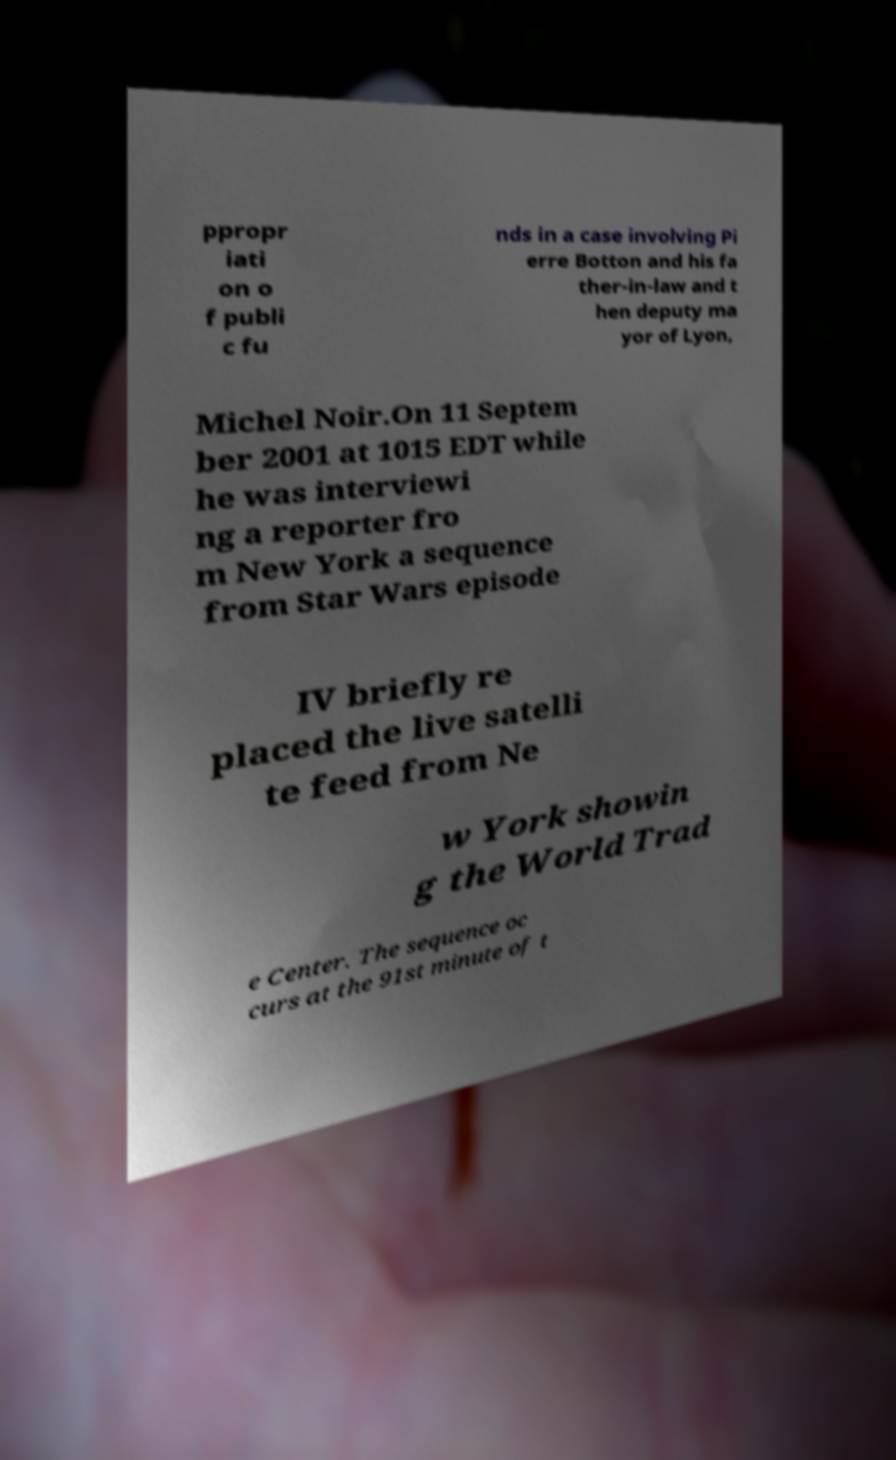Please identify and transcribe the text found in this image. ppropr iati on o f publi c fu nds in a case involving Pi erre Botton and his fa ther-in-law and t hen deputy ma yor of Lyon, Michel Noir.On 11 Septem ber 2001 at 1015 EDT while he was interviewi ng a reporter fro m New York a sequence from Star Wars episode IV briefly re placed the live satelli te feed from Ne w York showin g the World Trad e Center. The sequence oc curs at the 91st minute of t 